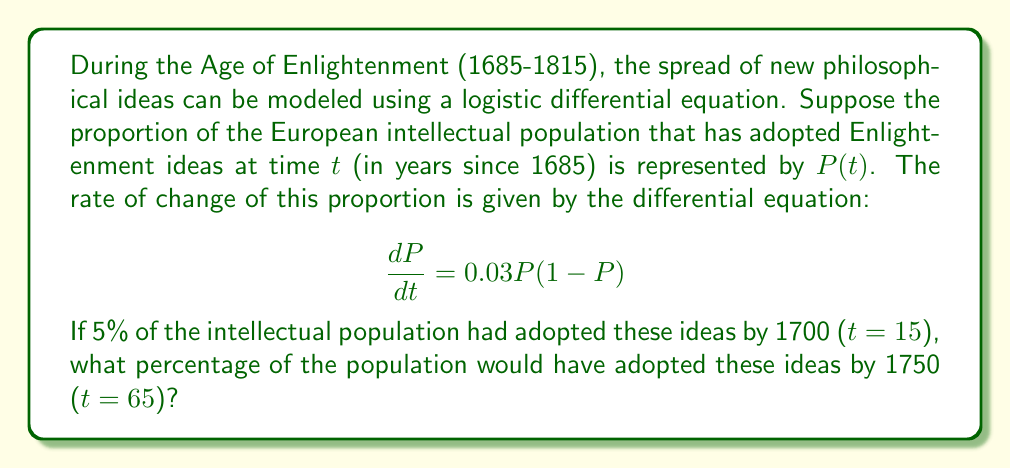Can you solve this math problem? To solve this problem, we need to use the logistic differential equation and its solution. Let's approach this step-by-step:

1) The given differential equation is:

   $$\frac{dP}{dt} = 0.03P(1-P)$$

2) This is a separable differential equation. The solution to this equation is the logistic function:

   $$P(t) = \frac{1}{1 + Ce^{-0.03t}}$$

   where $C$ is a constant that depends on the initial conditions.

3) We're given that $P(15) = 0.05$ (5% adoption by 1700). Let's use this to find $C$:

   $$0.05 = \frac{1}{1 + Ce^{-0.03(15)}}$$

4) Solving for $C$:

   $$1 + Ce^{-0.45} = 20$$
   $$Ce^{-0.45} = 19$$
   $$C = 19e^{0.45} \approx 30.04$$

5) Now we have our complete function:

   $$P(t) = \frac{1}{1 + 30.04e^{-0.03t}}$$

6) To find the percentage adoption by 1750, we need to calculate $P(65)$:

   $$P(65) = \frac{1}{1 + 30.04e^{-0.03(65)}}$$

7) Calculating this:

   $$P(65) \approx 0.6307$$

8) Converting to a percentage:

   $0.6307 * 100\% \approx 63.07\%$

Therefore, by 1750, approximately 63.07% of the European intellectual population would have adopted Enlightenment ideas according to this model.
Answer: 63.07% 